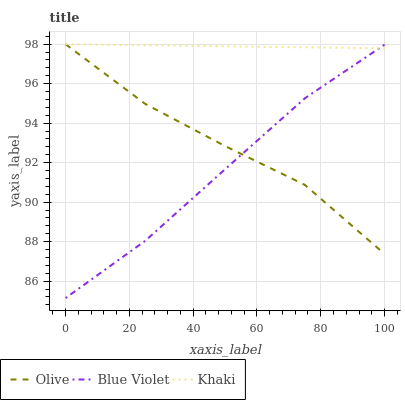Does Blue Violet have the minimum area under the curve?
Answer yes or no. Yes. Does Khaki have the maximum area under the curve?
Answer yes or no. Yes. Does Khaki have the minimum area under the curve?
Answer yes or no. No. Does Blue Violet have the maximum area under the curve?
Answer yes or no. No. Is Khaki the smoothest?
Answer yes or no. Yes. Is Olive the roughest?
Answer yes or no. Yes. Is Blue Violet the smoothest?
Answer yes or no. No. Is Blue Violet the roughest?
Answer yes or no. No. Does Blue Violet have the lowest value?
Answer yes or no. Yes. Does Khaki have the lowest value?
Answer yes or no. No. Does Khaki have the highest value?
Answer yes or no. Yes. Does Blue Violet have the highest value?
Answer yes or no. No. Does Olive intersect Blue Violet?
Answer yes or no. Yes. Is Olive less than Blue Violet?
Answer yes or no. No. Is Olive greater than Blue Violet?
Answer yes or no. No. 